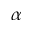<formula> <loc_0><loc_0><loc_500><loc_500>\alpha</formula> 